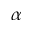<formula> <loc_0><loc_0><loc_500><loc_500>\alpha</formula> 